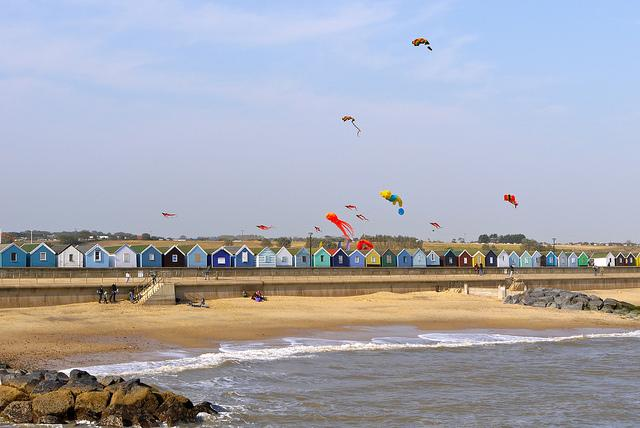Why do you need to frequently repair beach houses? Please explain your reasoning. environmental wear. Beachfront property is more subject to wear and tear. 